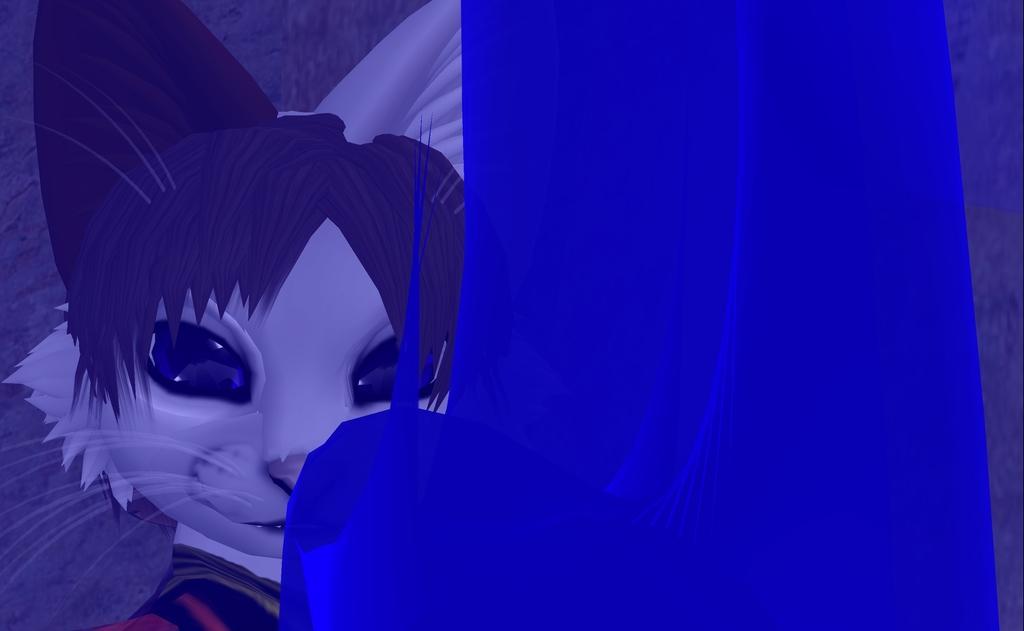How would you summarize this image in a sentence or two? This is an animated picture. I can see a cat, this is looking like a blue cloth. 